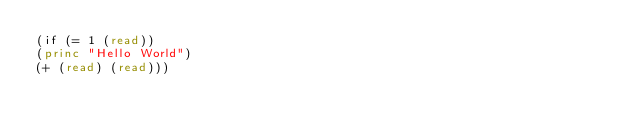Convert code to text. <code><loc_0><loc_0><loc_500><loc_500><_Lisp_>(if (= 1 (read))
(princ "Hello World")
(+ (read) (read)))</code> 